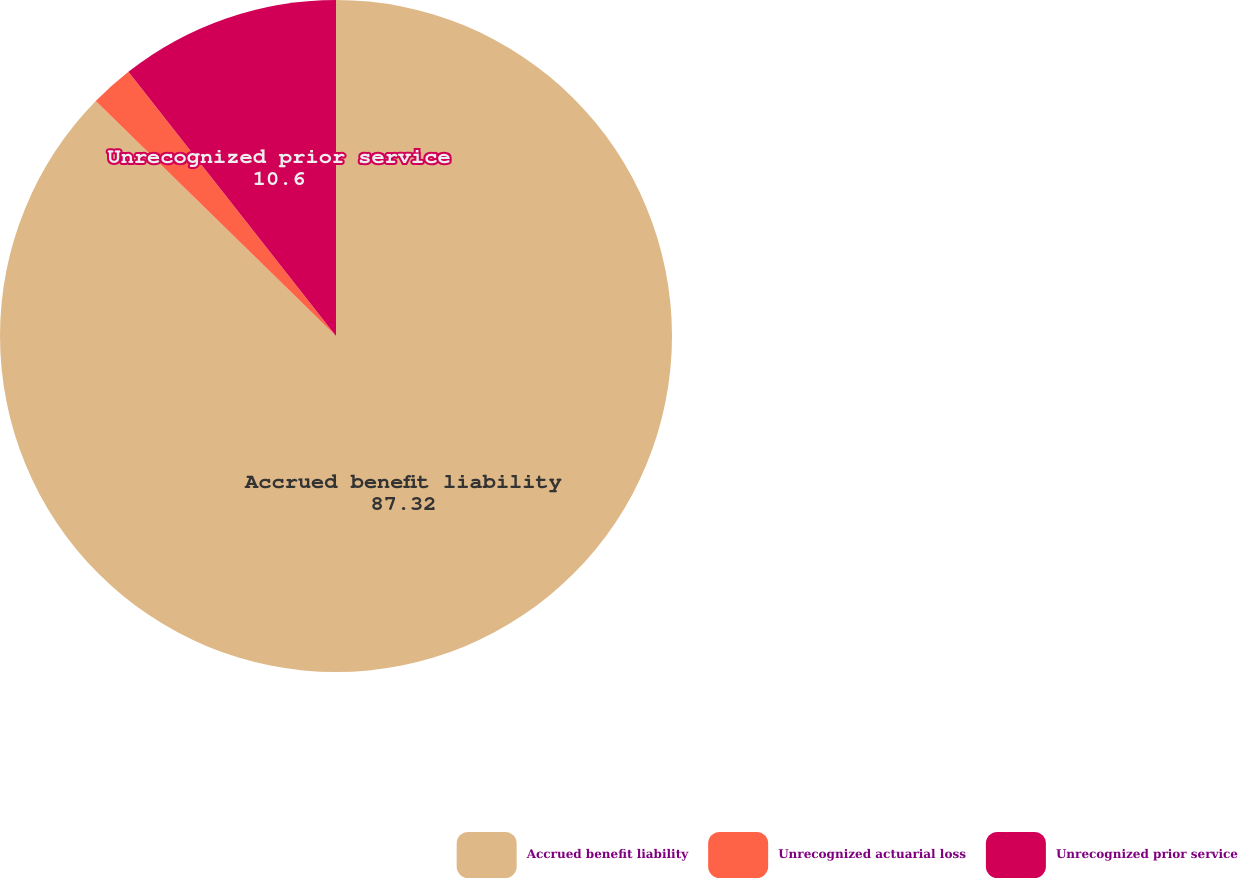Convert chart. <chart><loc_0><loc_0><loc_500><loc_500><pie_chart><fcel>Accrued benefit liability<fcel>Unrecognized actuarial loss<fcel>Unrecognized prior service<nl><fcel>87.32%<fcel>2.08%<fcel>10.6%<nl></chart> 